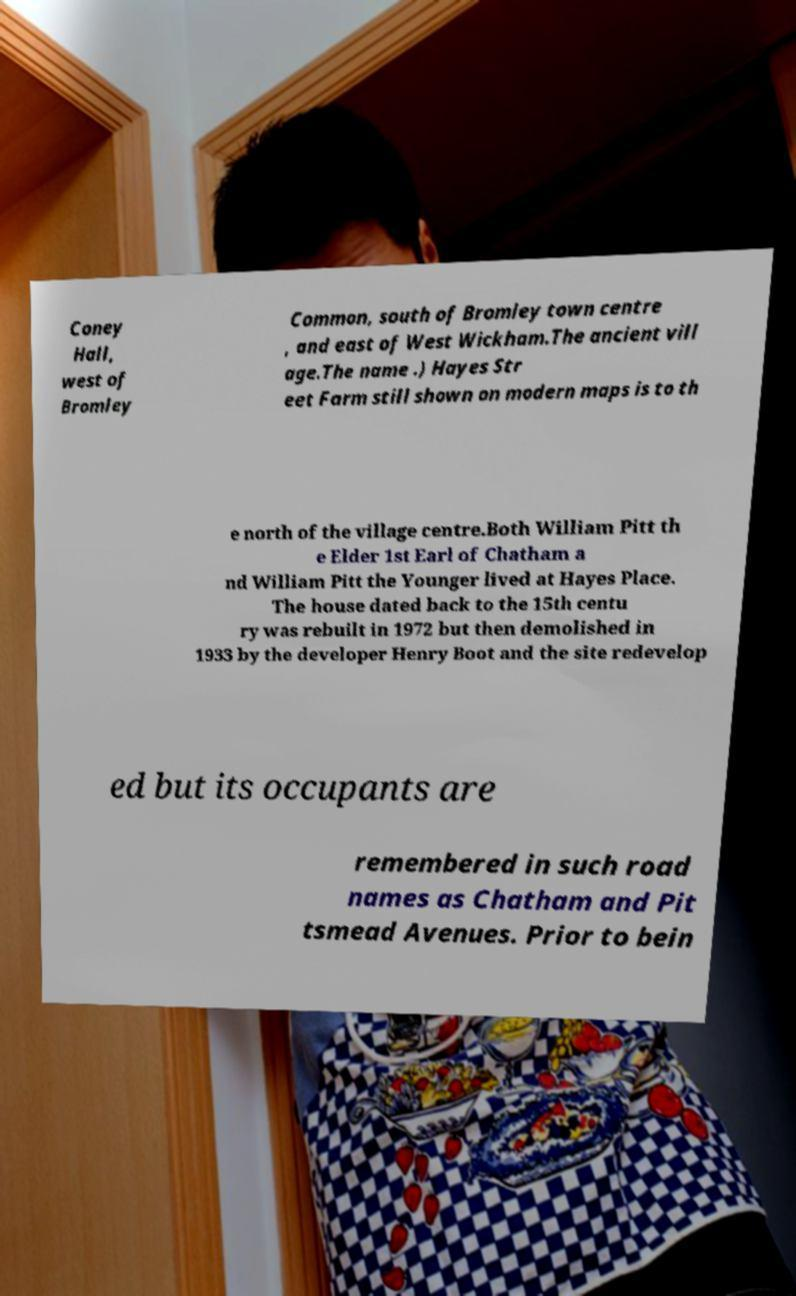Could you extract and type out the text from this image? Coney Hall, west of Bromley Common, south of Bromley town centre , and east of West Wickham.The ancient vill age.The name .) Hayes Str eet Farm still shown on modern maps is to th e north of the village centre.Both William Pitt th e Elder 1st Earl of Chatham a nd William Pitt the Younger lived at Hayes Place. The house dated back to the 15th centu ry was rebuilt in 1972 but then demolished in 1933 by the developer Henry Boot and the site redevelop ed but its occupants are remembered in such road names as Chatham and Pit tsmead Avenues. Prior to bein 